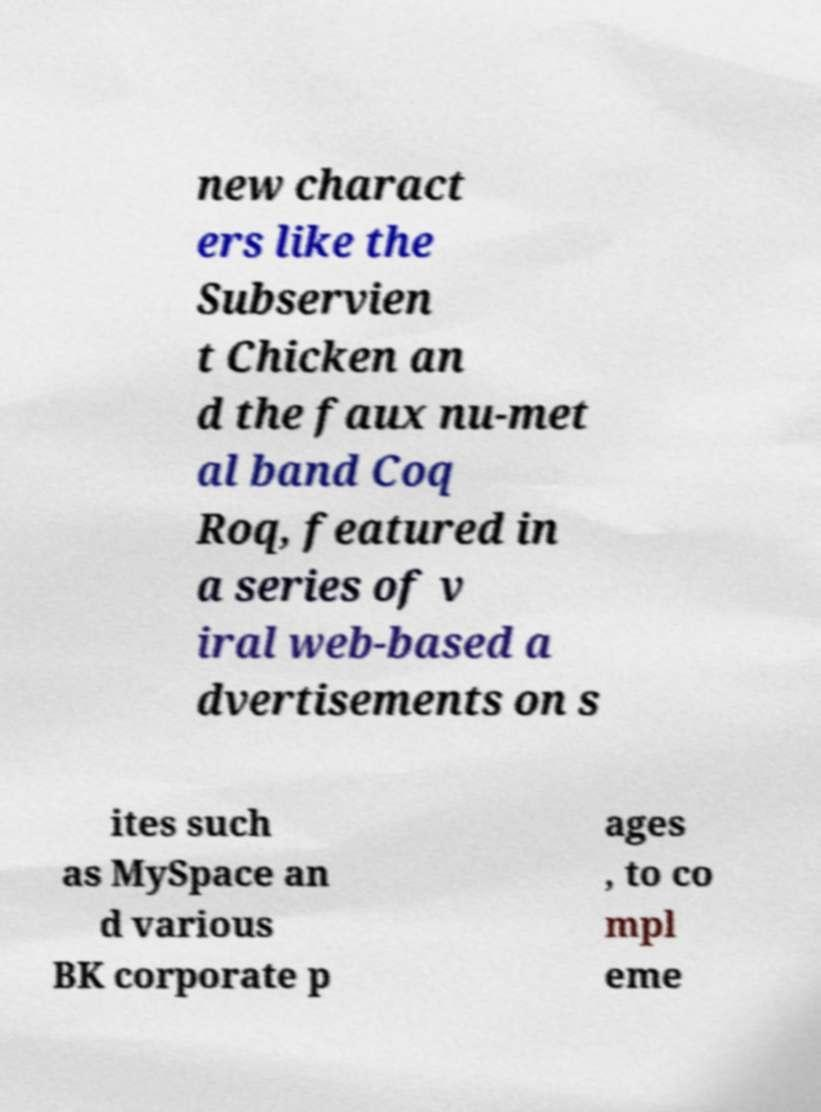I need the written content from this picture converted into text. Can you do that? new charact ers like the Subservien t Chicken an d the faux nu-met al band Coq Roq, featured in a series of v iral web-based a dvertisements on s ites such as MySpace an d various BK corporate p ages , to co mpl eme 